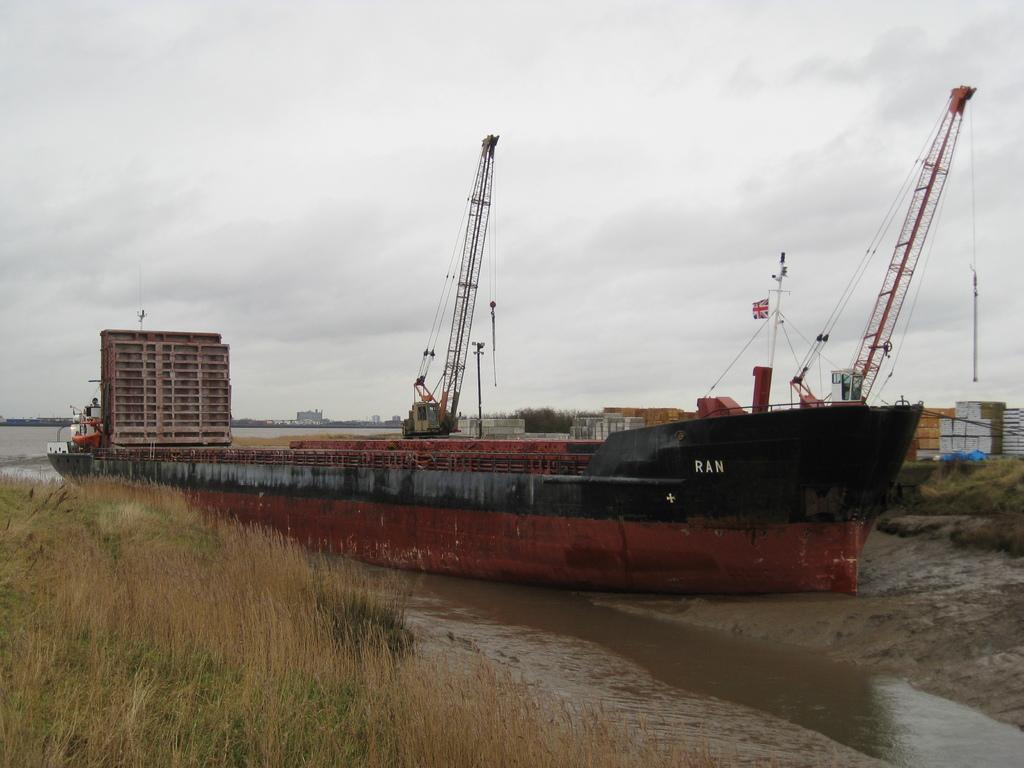What is the main subject in the center of the image? There is a boat in the center of the image. What is located at the bottom of the image? There is water and grass at the bottom of the image. What can be seen in the background of the image? There are buildings, cranes, and the sky visible in the background of the image. What type of news is being broadcasted from the boat in the image? There is no indication in the image that news is being broadcasted from the boat. What song is being sung by the cranes in the background of the image? There are no cranes singing in the image; they are simply visible in the background. 